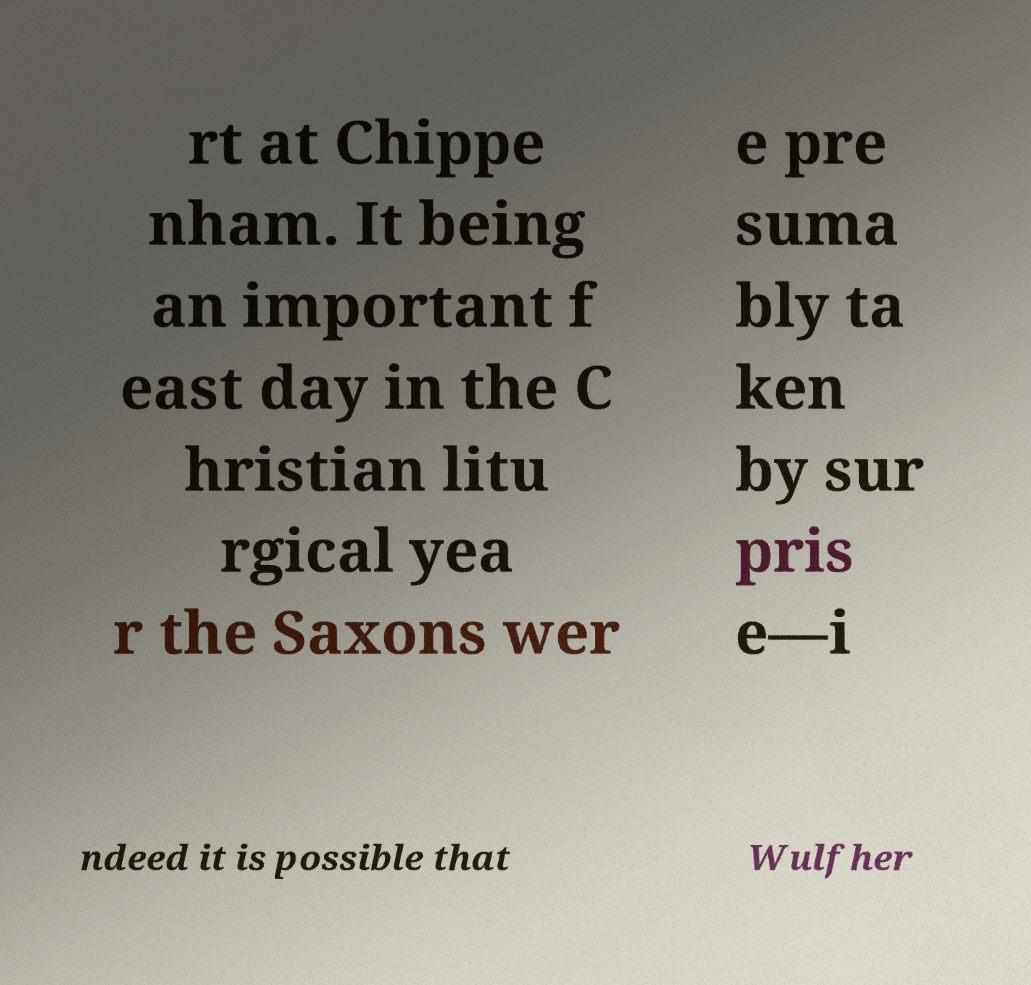Could you extract and type out the text from this image? rt at Chippe nham. It being an important f east day in the C hristian litu rgical yea r the Saxons wer e pre suma bly ta ken by sur pris e—i ndeed it is possible that Wulfher 